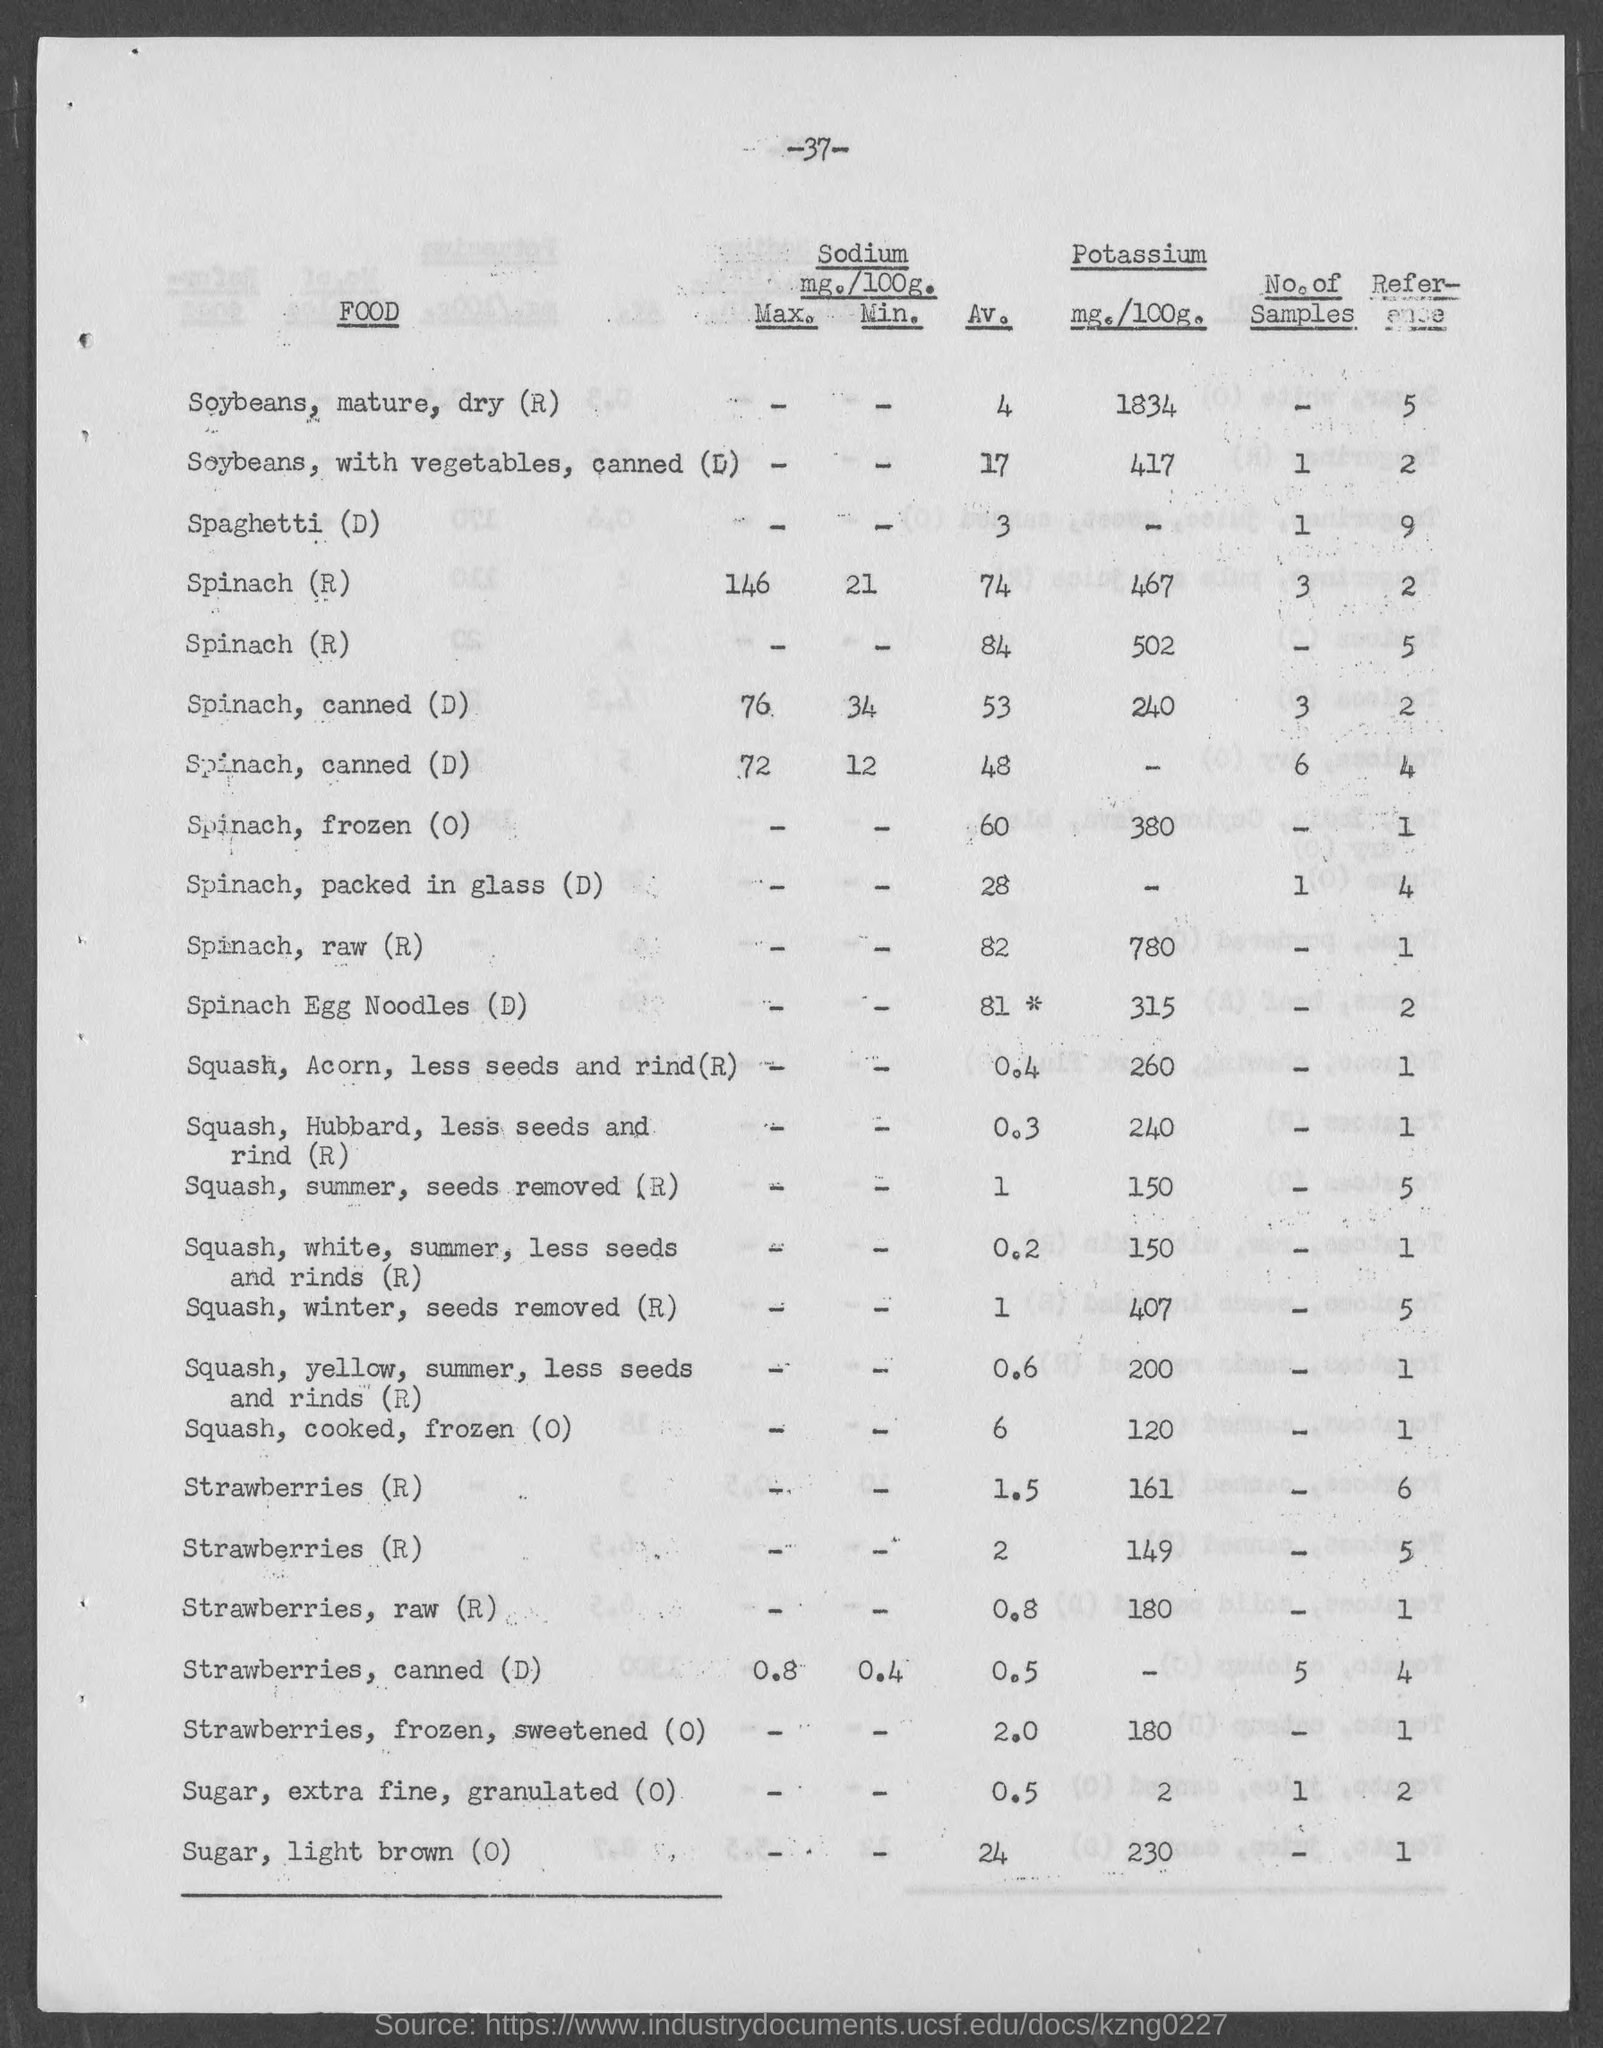How does the Potassium content of Squash, Winter compare to that of Spinach, raw? Spinach, raw, has a significantly higher Potassium content, with 780 mg per 100 grams, compared to the 407 mg per 100 grams found in the Winter Squash without seeds. 